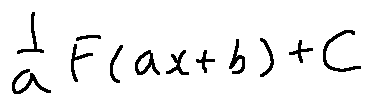<formula> <loc_0><loc_0><loc_500><loc_500>\frac { 1 } { a } F ( a x + b ) + C</formula> 